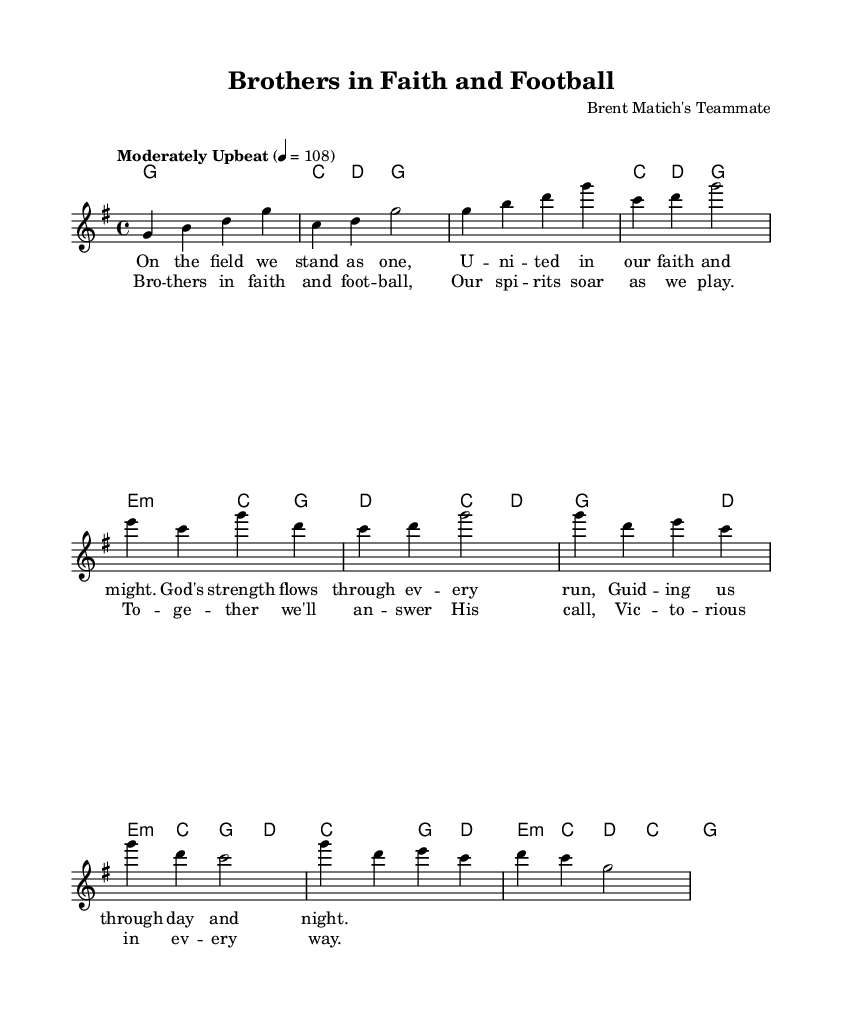What is the key signature of this music? The key signature is established in the global variable section of the code where it indicates the key of G major, which has one sharp (F#).
Answer: G major What is the time signature? The time signature appears in the global section of the code with a notation of 4/4, meaning there are four beats in a measure and the quarter note gets one beat.
Answer: 4/4 What is the tempo marking for the piece? The tempo marking is found in the global variable with "Moderately Upbeat" and a metronome marking of 108 beats per minute, indicating a lively pace.
Answer: Moderately Upbeat How many measures are in the chorus section? By examining the melody and harmonies for the chorus, we see that it consists of a total of four measures, as indicated by the number of chord and note groupings.
Answer: Four What is the title of the hymn? The title is specified in the header section of the code, marking it as "Brothers in Faith and Football," reflecting its content that combines team spirit with religious themes.
Answer: Brothers in Faith and Football How is the melody structured in the chorus? The chorus melody has a repetitive structure where the notes follow a pattern: each musical phrase is akin to a call-and-response format, creating an uplifting atmosphere.
Answer: Repetitive structure What is the primary theme of the lyrics? The lyrics primarily celebrate camaraderie and teamwork, highlighting brothers in both faith and football coming together for strength and support.
Answer: Camaraderie and teamwork 